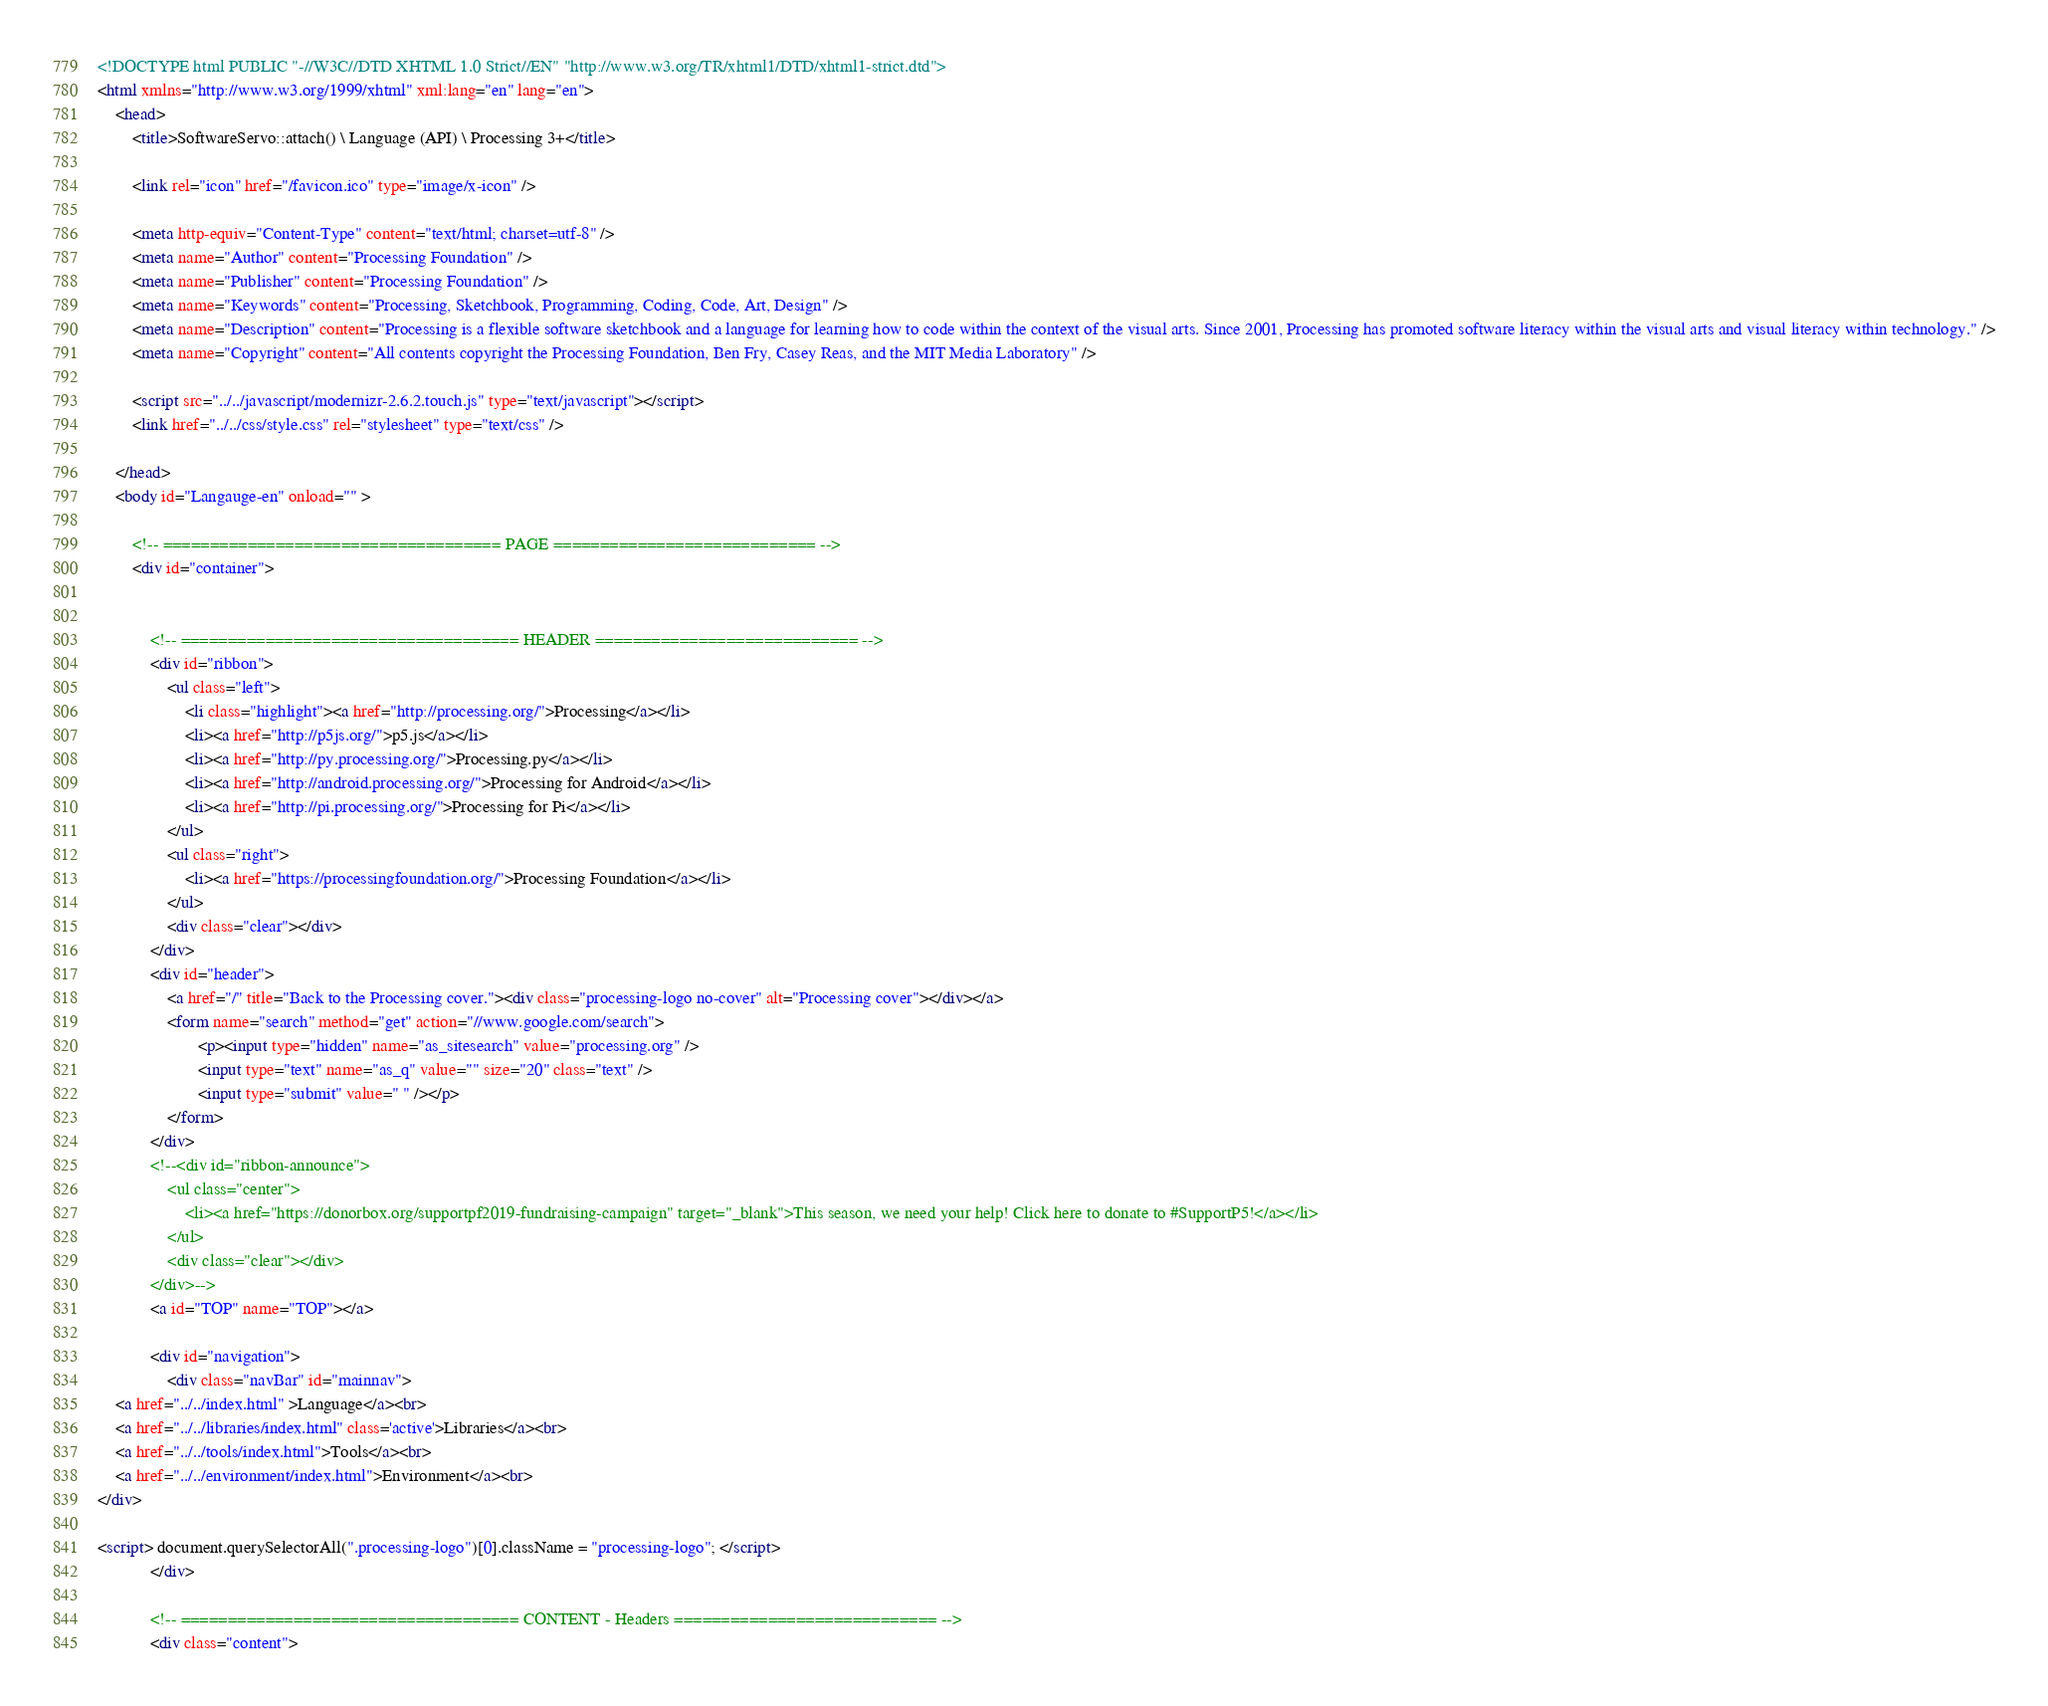Convert code to text. <code><loc_0><loc_0><loc_500><loc_500><_HTML_><!DOCTYPE html PUBLIC "-//W3C//DTD XHTML 1.0 Strict//EN" "http://www.w3.org/TR/xhtml1/DTD/xhtml1-strict.dtd">
<html xmlns="http://www.w3.org/1999/xhtml" xml:lang="en" lang="en">
	<head>
		<title>SoftwareServo::attach() \ Language (API) \ Processing 3+</title>

		<link rel="icon" href="/favicon.ico" type="image/x-icon" />

		<meta http-equiv="Content-Type" content="text/html; charset=utf-8" />
		<meta name="Author" content="Processing Foundation" />
		<meta name="Publisher" content="Processing Foundation" />
		<meta name="Keywords" content="Processing, Sketchbook, Programming, Coding, Code, Art, Design" />
		<meta name="Description" content="Processing is a flexible software sketchbook and a language for learning how to code within the context of the visual arts. Since 2001, Processing has promoted software literacy within the visual arts and visual literacy within technology." />
		<meta name="Copyright" content="All contents copyright the Processing Foundation, Ben Fry, Casey Reas, and the MIT Media Laboratory" />

		<script src="../../javascript/modernizr-2.6.2.touch.js" type="text/javascript"></script>
		<link href="../../css/style.css" rel="stylesheet" type="text/css" />

	</head>
	<body id="Langauge-en" onload="" >

		<!-- ==================================== PAGE ============================ -->
		<div id="container">


			<!-- ==================================== HEADER ============================ -->
			<div id="ribbon">
				<ul class="left">
					<li class="highlight"><a href="http://processing.org/">Processing</a></li>
					<li><a href="http://p5js.org/">p5.js</a></li>
					<li><a href="http://py.processing.org/">Processing.py</a></li>
					<li><a href="http://android.processing.org/">Processing for Android</a></li>
					<li><a href="http://pi.processing.org/">Processing for Pi</a></li>
				</ul>
				<ul class="right">
					<li><a href="https://processingfoundation.org/">Processing Foundation</a></li>
				</ul>
				<div class="clear"></div>
			</div>
			<div id="header">
				<a href="/" title="Back to the Processing cover."><div class="processing-logo no-cover" alt="Processing cover"></div></a>
				<form name="search" method="get" action="//www.google.com/search">
				       <p><input type="hidden" name="as_sitesearch" value="processing.org" />
				       <input type="text" name="as_q" value="" size="20" class="text" />
				       <input type="submit" value=" " /></p>
				</form>
			</div>
			<!--<div id="ribbon-announce">
				<ul class="center">
					<li><a href="https://donorbox.org/supportpf2019-fundraising-campaign" target="_blank">This season, we need your help! Click here to donate to #SupportP5!</a></li>
				</ul>
				<div class="clear"></div>
			</div>-->
			<a id="TOP" name="TOP"></a>

			<div id="navigation">
				<div class="navBar" id="mainnav">
	<a href="../../index.html" >Language</a><br>
	<a href="../../libraries/index.html" class='active'>Libraries</a><br>
	<a href="../../tools/index.html">Tools</a><br>
	<a href="../../environment/index.html">Environment</a><br>
</div>

<script> document.querySelectorAll(".processing-logo")[0].className = "processing-logo"; </script>
			</div>

			<!-- ==================================== CONTENT - Headers ============================ -->
			<div class="content">
</code> 